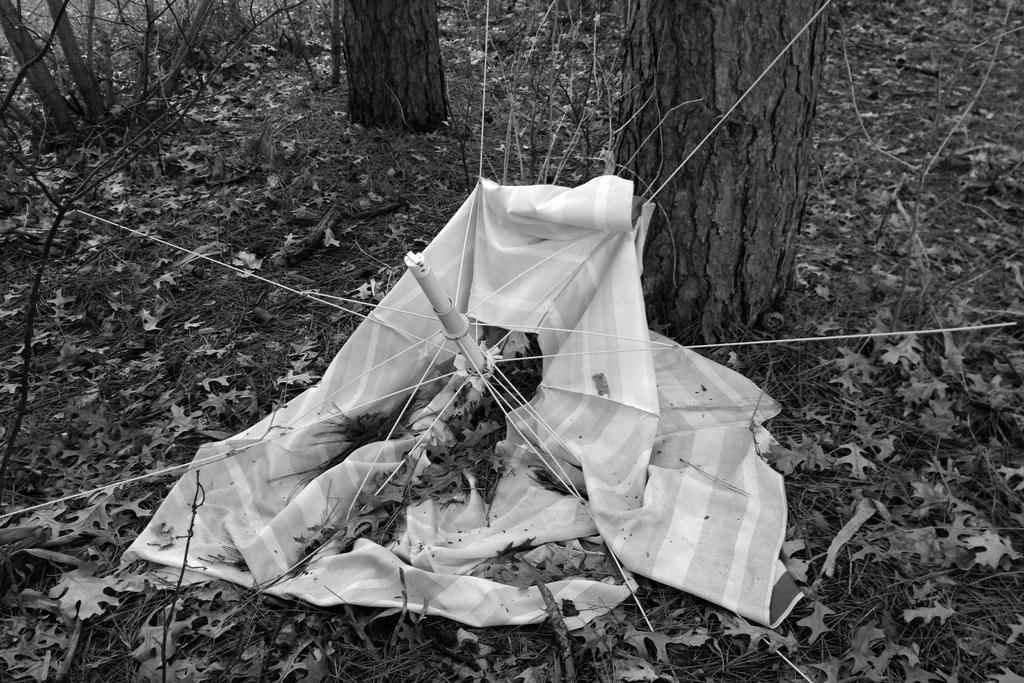Can you describe this image briefly? In this picture I can see there is an umbrella, it has metal rods, it has a white cloth and there are few dry leaves on the floor, there are trees in the backdrop, there are plants and this is a black and white image. 